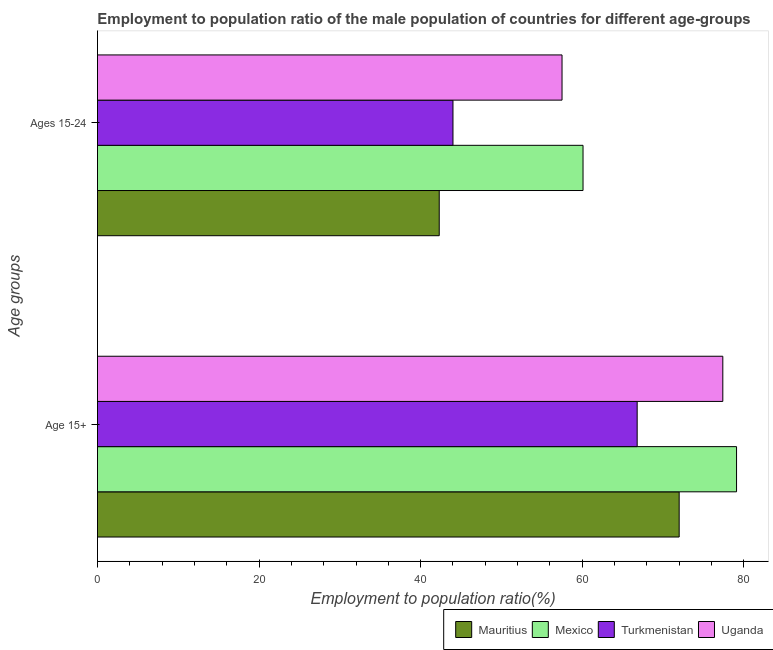How many groups of bars are there?
Offer a terse response. 2. Are the number of bars on each tick of the Y-axis equal?
Provide a succinct answer. Yes. How many bars are there on the 2nd tick from the top?
Your answer should be compact. 4. How many bars are there on the 2nd tick from the bottom?
Give a very brief answer. 4. What is the label of the 2nd group of bars from the top?
Give a very brief answer. Age 15+. What is the employment to population ratio(age 15-24) in Turkmenistan?
Give a very brief answer. 44. Across all countries, what is the maximum employment to population ratio(age 15-24)?
Offer a very short reply. 60.1. Across all countries, what is the minimum employment to population ratio(age 15-24)?
Provide a short and direct response. 42.3. In which country was the employment to population ratio(age 15-24) minimum?
Make the answer very short. Mauritius. What is the total employment to population ratio(age 15+) in the graph?
Provide a succinct answer. 295.3. What is the difference between the employment to population ratio(age 15+) in Mexico and that in Turkmenistan?
Offer a terse response. 12.3. What is the difference between the employment to population ratio(age 15-24) in Mexico and the employment to population ratio(age 15+) in Mauritius?
Your answer should be very brief. -11.9. What is the average employment to population ratio(age 15+) per country?
Make the answer very short. 73.83. What is the difference between the employment to population ratio(age 15-24) and employment to population ratio(age 15+) in Uganda?
Give a very brief answer. -19.9. In how many countries, is the employment to population ratio(age 15-24) greater than 60 %?
Your response must be concise. 1. What is the ratio of the employment to population ratio(age 15+) in Turkmenistan to that in Mauritius?
Offer a very short reply. 0.93. Is the employment to population ratio(age 15+) in Mexico less than that in Uganda?
Your answer should be very brief. No. What does the 4th bar from the top in Ages 15-24 represents?
Provide a short and direct response. Mauritius. How many countries are there in the graph?
Offer a terse response. 4. Are the values on the major ticks of X-axis written in scientific E-notation?
Provide a short and direct response. No. How are the legend labels stacked?
Your answer should be very brief. Horizontal. What is the title of the graph?
Keep it short and to the point. Employment to population ratio of the male population of countries for different age-groups. Does "Austria" appear as one of the legend labels in the graph?
Provide a short and direct response. No. What is the label or title of the Y-axis?
Your answer should be compact. Age groups. What is the Employment to population ratio(%) of Mauritius in Age 15+?
Provide a succinct answer. 72. What is the Employment to population ratio(%) of Mexico in Age 15+?
Make the answer very short. 79.1. What is the Employment to population ratio(%) in Turkmenistan in Age 15+?
Your answer should be very brief. 66.8. What is the Employment to population ratio(%) in Uganda in Age 15+?
Your answer should be compact. 77.4. What is the Employment to population ratio(%) in Mauritius in Ages 15-24?
Make the answer very short. 42.3. What is the Employment to population ratio(%) in Mexico in Ages 15-24?
Make the answer very short. 60.1. What is the Employment to population ratio(%) of Turkmenistan in Ages 15-24?
Offer a very short reply. 44. What is the Employment to population ratio(%) in Uganda in Ages 15-24?
Your response must be concise. 57.5. Across all Age groups, what is the maximum Employment to population ratio(%) of Mauritius?
Provide a succinct answer. 72. Across all Age groups, what is the maximum Employment to population ratio(%) of Mexico?
Your response must be concise. 79.1. Across all Age groups, what is the maximum Employment to population ratio(%) of Turkmenistan?
Give a very brief answer. 66.8. Across all Age groups, what is the maximum Employment to population ratio(%) of Uganda?
Your response must be concise. 77.4. Across all Age groups, what is the minimum Employment to population ratio(%) in Mauritius?
Keep it short and to the point. 42.3. Across all Age groups, what is the minimum Employment to population ratio(%) in Mexico?
Provide a succinct answer. 60.1. Across all Age groups, what is the minimum Employment to population ratio(%) in Uganda?
Your answer should be very brief. 57.5. What is the total Employment to population ratio(%) of Mauritius in the graph?
Provide a succinct answer. 114.3. What is the total Employment to population ratio(%) of Mexico in the graph?
Keep it short and to the point. 139.2. What is the total Employment to population ratio(%) in Turkmenistan in the graph?
Provide a succinct answer. 110.8. What is the total Employment to population ratio(%) in Uganda in the graph?
Provide a succinct answer. 134.9. What is the difference between the Employment to population ratio(%) of Mauritius in Age 15+ and that in Ages 15-24?
Ensure brevity in your answer.  29.7. What is the difference between the Employment to population ratio(%) of Turkmenistan in Age 15+ and that in Ages 15-24?
Make the answer very short. 22.8. What is the difference between the Employment to population ratio(%) of Mauritius in Age 15+ and the Employment to population ratio(%) of Turkmenistan in Ages 15-24?
Make the answer very short. 28. What is the difference between the Employment to population ratio(%) of Mexico in Age 15+ and the Employment to population ratio(%) of Turkmenistan in Ages 15-24?
Provide a succinct answer. 35.1. What is the difference between the Employment to population ratio(%) of Mexico in Age 15+ and the Employment to population ratio(%) of Uganda in Ages 15-24?
Provide a short and direct response. 21.6. What is the difference between the Employment to population ratio(%) of Turkmenistan in Age 15+ and the Employment to population ratio(%) of Uganda in Ages 15-24?
Make the answer very short. 9.3. What is the average Employment to population ratio(%) in Mauritius per Age groups?
Provide a succinct answer. 57.15. What is the average Employment to population ratio(%) in Mexico per Age groups?
Your answer should be very brief. 69.6. What is the average Employment to population ratio(%) in Turkmenistan per Age groups?
Your answer should be very brief. 55.4. What is the average Employment to population ratio(%) in Uganda per Age groups?
Your response must be concise. 67.45. What is the difference between the Employment to population ratio(%) of Mauritius and Employment to population ratio(%) of Uganda in Age 15+?
Give a very brief answer. -5.4. What is the difference between the Employment to population ratio(%) of Mexico and Employment to population ratio(%) of Turkmenistan in Age 15+?
Ensure brevity in your answer.  12.3. What is the difference between the Employment to population ratio(%) of Mauritius and Employment to population ratio(%) of Mexico in Ages 15-24?
Give a very brief answer. -17.8. What is the difference between the Employment to population ratio(%) in Mauritius and Employment to population ratio(%) in Uganda in Ages 15-24?
Keep it short and to the point. -15.2. What is the difference between the Employment to population ratio(%) of Mexico and Employment to population ratio(%) of Uganda in Ages 15-24?
Provide a short and direct response. 2.6. What is the ratio of the Employment to population ratio(%) of Mauritius in Age 15+ to that in Ages 15-24?
Keep it short and to the point. 1.7. What is the ratio of the Employment to population ratio(%) of Mexico in Age 15+ to that in Ages 15-24?
Ensure brevity in your answer.  1.32. What is the ratio of the Employment to population ratio(%) in Turkmenistan in Age 15+ to that in Ages 15-24?
Your answer should be very brief. 1.52. What is the ratio of the Employment to population ratio(%) in Uganda in Age 15+ to that in Ages 15-24?
Give a very brief answer. 1.35. What is the difference between the highest and the second highest Employment to population ratio(%) of Mauritius?
Provide a short and direct response. 29.7. What is the difference between the highest and the second highest Employment to population ratio(%) of Turkmenistan?
Keep it short and to the point. 22.8. What is the difference between the highest and the lowest Employment to population ratio(%) in Mauritius?
Provide a short and direct response. 29.7. What is the difference between the highest and the lowest Employment to population ratio(%) of Mexico?
Keep it short and to the point. 19. What is the difference between the highest and the lowest Employment to population ratio(%) of Turkmenistan?
Keep it short and to the point. 22.8. 